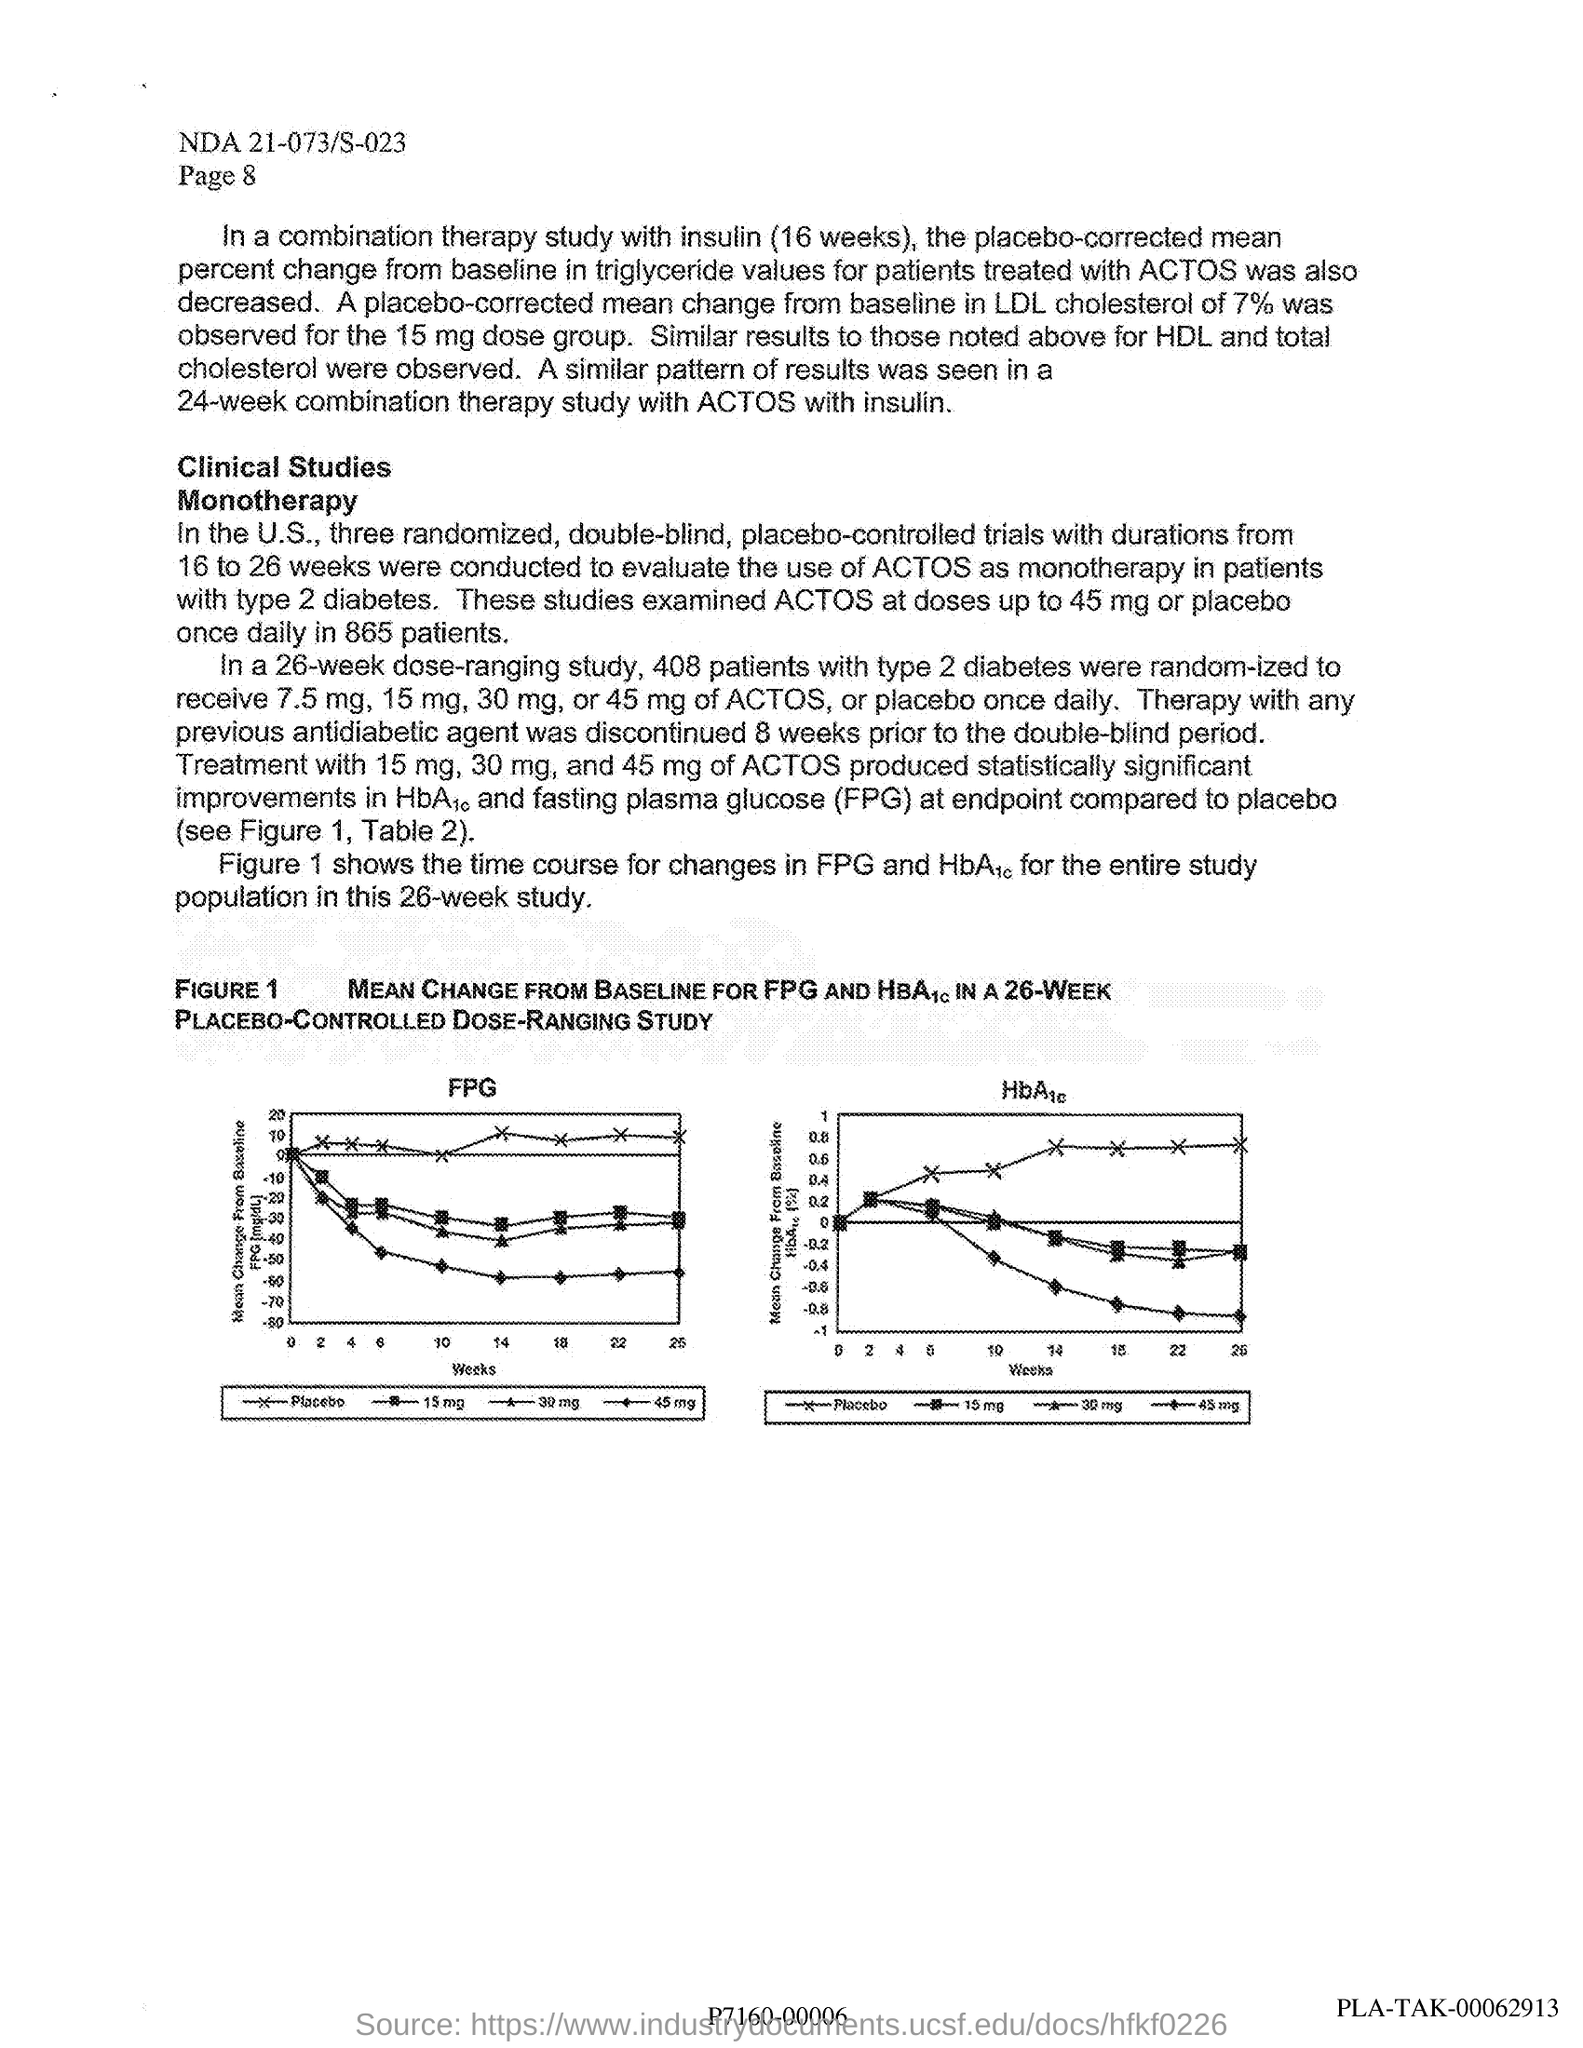Which is used as 'monotherapy' in patients  with type 2 diabetes?
Offer a terse response. ACTOS. What is the entire population study time ?
Your answer should be compact. 26 weeks. What is the page number given at the header ?
Your answer should be very brief. Page 8. What is the document code written at the header?
Your response must be concise. NDA 21-073/S-023. What is the value plotted on X-axis in graphs?
Your answer should be very brief. Weeks. 